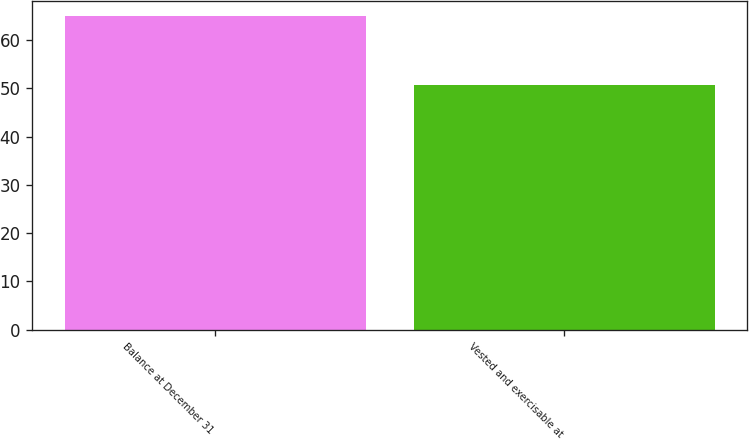Convert chart to OTSL. <chart><loc_0><loc_0><loc_500><loc_500><bar_chart><fcel>Balance at December 31<fcel>Vested and exercisable at<nl><fcel>64.98<fcel>50.72<nl></chart> 